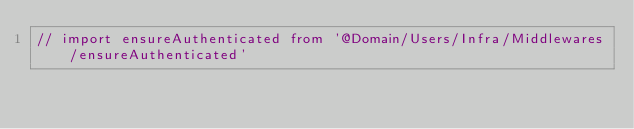<code> <loc_0><loc_0><loc_500><loc_500><_TypeScript_>// import ensureAuthenticated from '@Domain/Users/Infra/Middlewares/ensureAuthenticated'</code> 